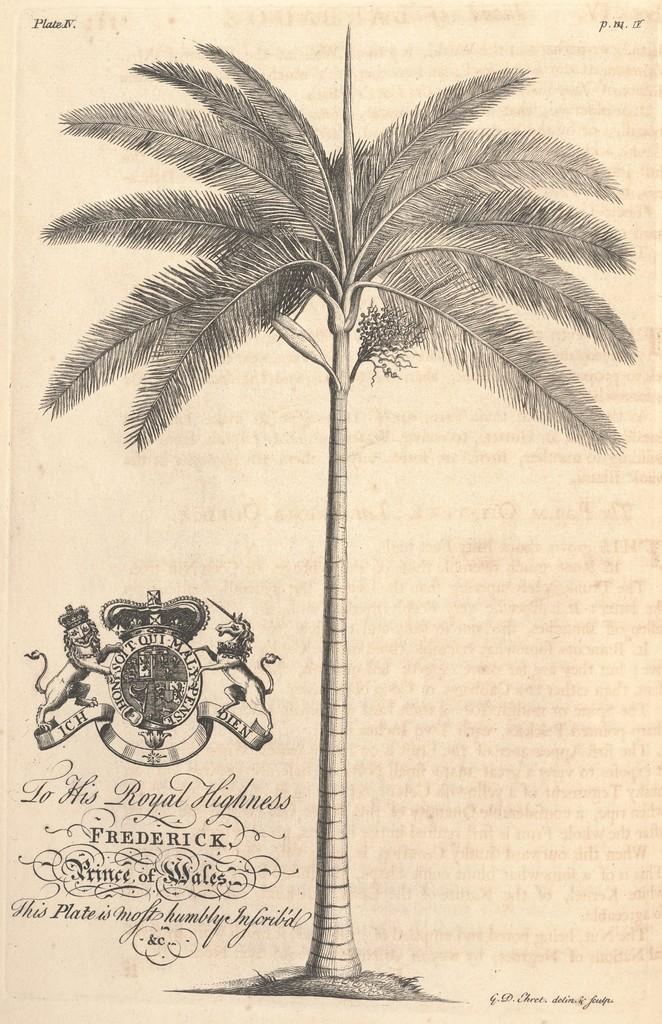What is depicted in the drawing in the image? There is a drawing of a tree in the image. What else can be seen in the image besides the drawing? There is a logo and text in the image. How many jellyfish are swimming in the image? There are no jellyfish present in the image. What type of sponge is being used to create the drawing in the image? There is no sponge mentioned or depicted in the image; it is a drawing of a tree. 